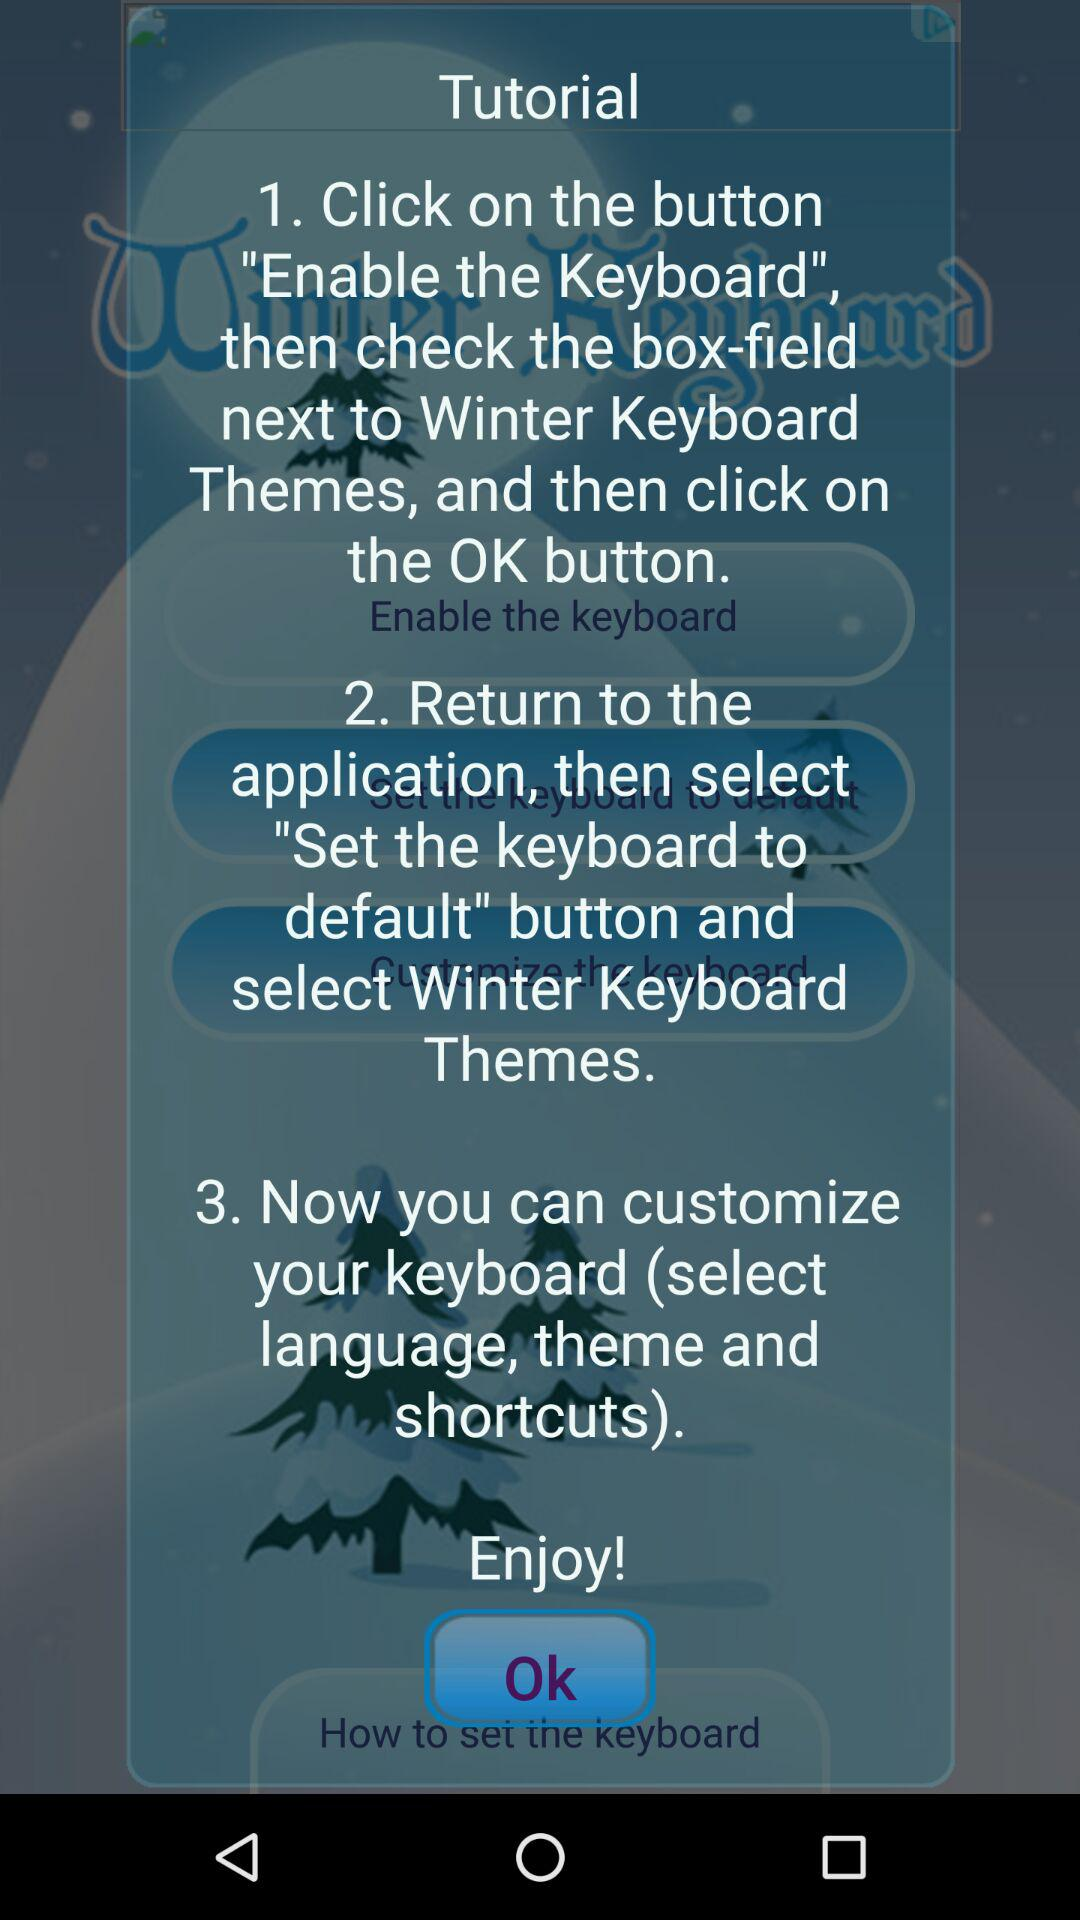How many steps are there in the tutorial?
Answer the question using a single word or phrase. 3 